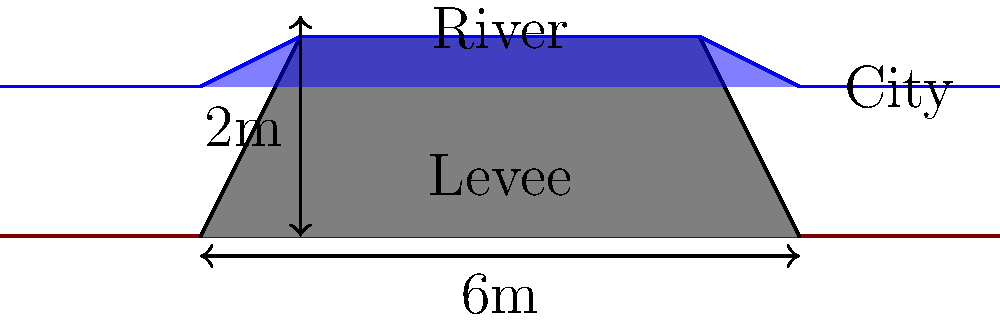In the cross-sectional diagram of a levee system, what is the primary function of the levee, and how does its height relate to the water level during a flood event? To understand the function of the levee and its relation to water level, let's analyze the diagram step-by-step:

1. Levee structure: The levee is represented by the gray trapezoidal shape in the middle of the diagram.

2. Water level: The blue area represents the river water, which is at a higher level than the surrounding land.

3. Primary function: The levee's main purpose is to contain the river water and prevent it from flooding the adjacent city area.

4. Height relationship:
   a. The levee's height is 2 meters, as indicated by the vertical dimension line.
   b. The water level is shown to reach the top of the levee during a flood event.

5. Safety margin: In proper flood prevention design, the levee height should exceed the expected flood water level to provide a safety margin. In this case, the water is at the maximum safe level.

6. Flood prevention: By being higher than the surrounding land and at least as high as the flood water level, the levee creates a barrier that prevents water from flowing into the protected area (the city).

7. Importance for urban areas: This system is crucial for cities like Tokyo, which may face increased flood risks due to extreme weather events and rising sea levels.

The levee's effectiveness in flood prevention relies on its height being sufficient to contain the expected water level during flood events, thereby protecting the urban area behind it.
Answer: To contain river water and prevent flooding; levee height must meet or exceed flood water level. 